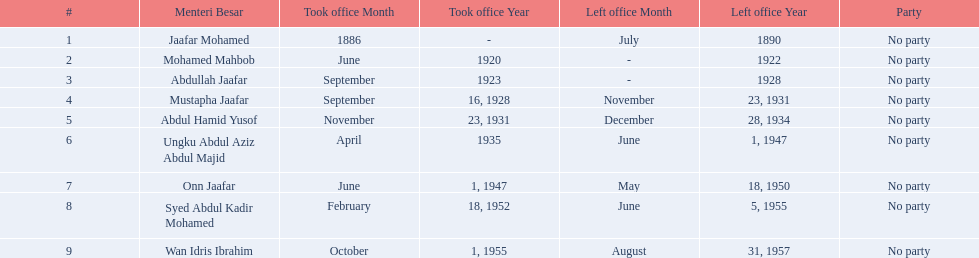Which menteri besars took office in the 1920's? Mohamed Mahbob, Abdullah Jaafar, Mustapha Jaafar. Of those men, who was only in office for 2 years? Mohamed Mahbob. 